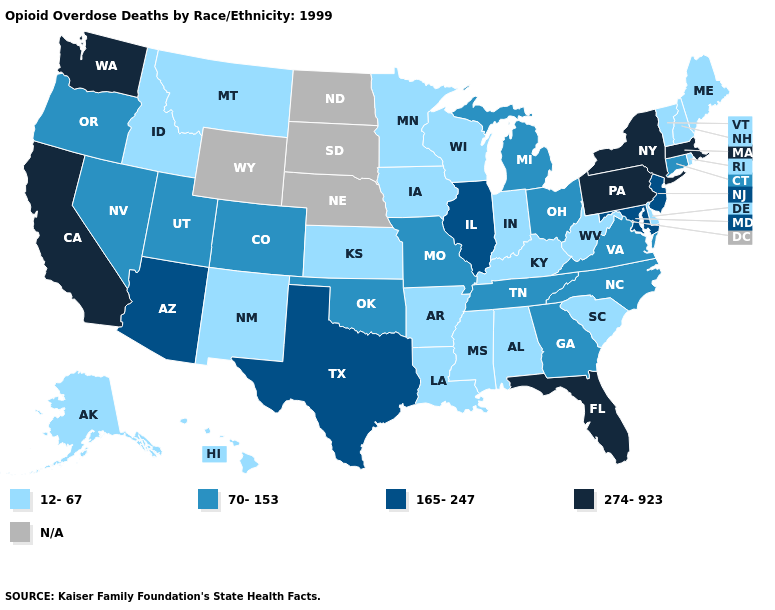Which states hav the highest value in the Northeast?
Write a very short answer. Massachusetts, New York, Pennsylvania. Is the legend a continuous bar?
Answer briefly. No. Name the states that have a value in the range N/A?
Answer briefly. Nebraska, North Dakota, South Dakota, Wyoming. Name the states that have a value in the range 70-153?
Answer briefly. Colorado, Connecticut, Georgia, Michigan, Missouri, Nevada, North Carolina, Ohio, Oklahoma, Oregon, Tennessee, Utah, Virginia. What is the lowest value in the USA?
Answer briefly. 12-67. Name the states that have a value in the range 274-923?
Quick response, please. California, Florida, Massachusetts, New York, Pennsylvania, Washington. What is the value of Kentucky?
Write a very short answer. 12-67. Does Wisconsin have the highest value in the MidWest?
Answer briefly. No. Which states have the lowest value in the MidWest?
Give a very brief answer. Indiana, Iowa, Kansas, Minnesota, Wisconsin. What is the value of Pennsylvania?
Be succinct. 274-923. What is the value of New York?
Give a very brief answer. 274-923. Does the first symbol in the legend represent the smallest category?
Answer briefly. Yes. What is the highest value in the USA?
Be succinct. 274-923. Name the states that have a value in the range N/A?
Answer briefly. Nebraska, North Dakota, South Dakota, Wyoming. What is the highest value in the West ?
Answer briefly. 274-923. 